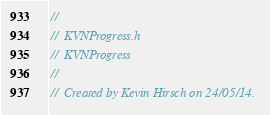<code> <loc_0><loc_0><loc_500><loc_500><_C_>//
//  KVNProgress.h
//  KVNProgress
//
//  Created by Kevin Hirsch on 24/05/14.</code> 